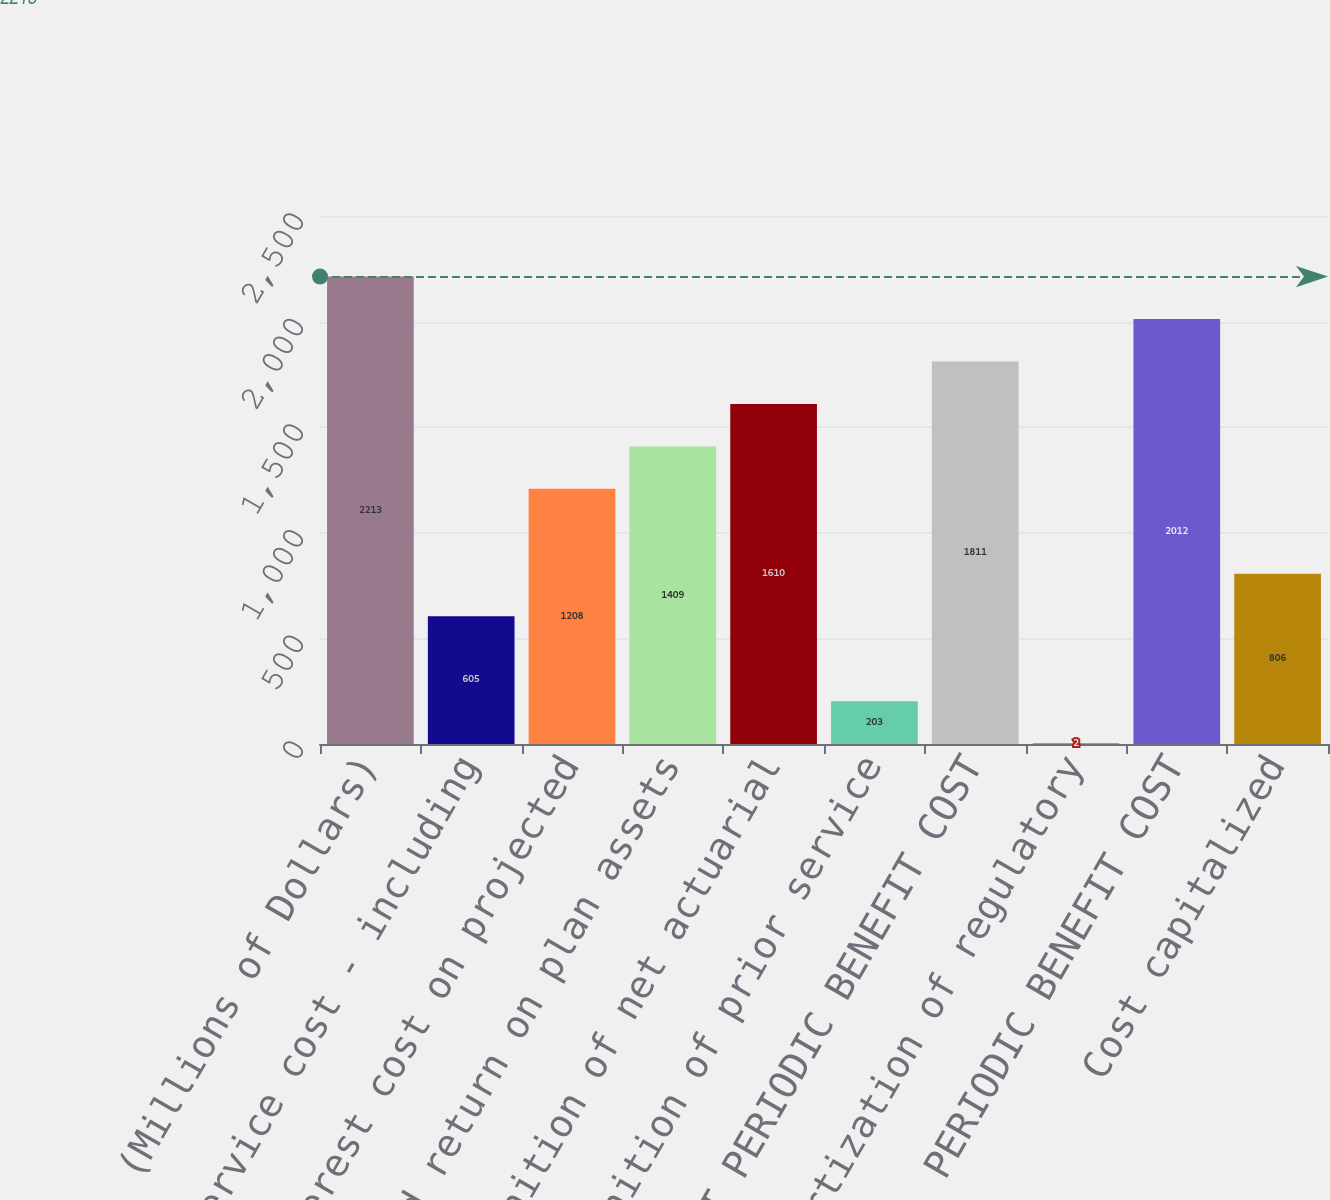Convert chart to OTSL. <chart><loc_0><loc_0><loc_500><loc_500><bar_chart><fcel>(Millions of Dollars)<fcel>Service cost - including<fcel>Interest cost on projected<fcel>Expected return on plan assets<fcel>Recognition of net actuarial<fcel>Recognition of prior service<fcel>NET PERIODIC BENEFIT COST<fcel>Amortization of regulatory<fcel>TOTAL PERIODIC BENEFIT COST<fcel>Cost capitalized<nl><fcel>2213<fcel>605<fcel>1208<fcel>1409<fcel>1610<fcel>203<fcel>1811<fcel>2<fcel>2012<fcel>806<nl></chart> 